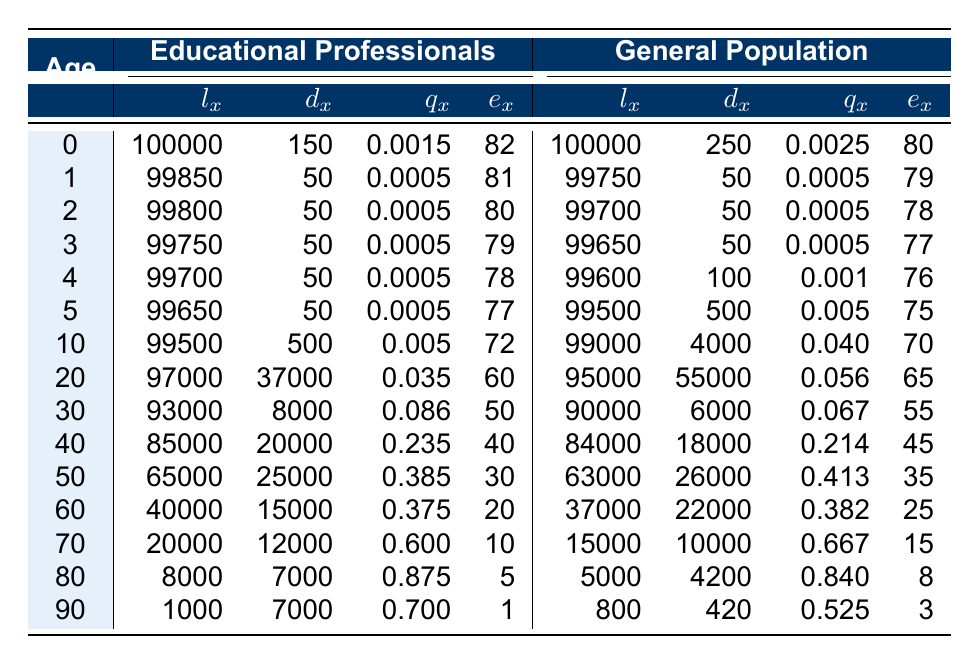What is the value of l_x for educational professionals at age 60? Referring to the table, under the row for age 60, the value for l_x for educational professionals is 40000.
Answer: 40000 What is the death probability q_x for the general population at age 80? Looking at the table for age 80, the value for q_x for the general population is 0.840.
Answer: 0.840 What is the difference in the number of deaths (d_x) between educational professionals and the general population at age 50? For educational professionals at age 50, d_x is 25000, while for the general population it is 26000. The difference is 26000 - 25000 = 1000.
Answer: 1000 How many educational professionals aged 40 or younger are alive according to the table? We sum l_x values for ages 0, 1, 2, 3, 4, 5, and 10. Total is 100000 + 99850 + 99800 + 99750 + 99700 + 99650 + 99500 = 598750.
Answer: 598750 Is it true that the average remaining life expectancy e_x for educational professionals decreases more sharply than that of the general population after age 60? Upon examining the remaining life expectancy under e_x for both groups, educational professionals drop from 20 years at age 60 to 1 year at age 90, while the general population decreases from 25 years at age 60 to 3 years at age 90. This indicates a steeper decline for educational professionals.
Answer: Yes What is the average remaining life expectancy for individuals aged 30 in both groups? Educational professionals have a remaining life expectancy e_x of 50, and the general population has 55. The average is (50 + 55) / 2 = 52.5.
Answer: 52.5 What is the total number of deaths reported for educational professionals from ages 20 to 30? For educational professionals at ages 20 and 30, d_x values are 37000 and 8000, respectively. Adding these gives 37000 + 8000 = 45000.
Answer: 45000 